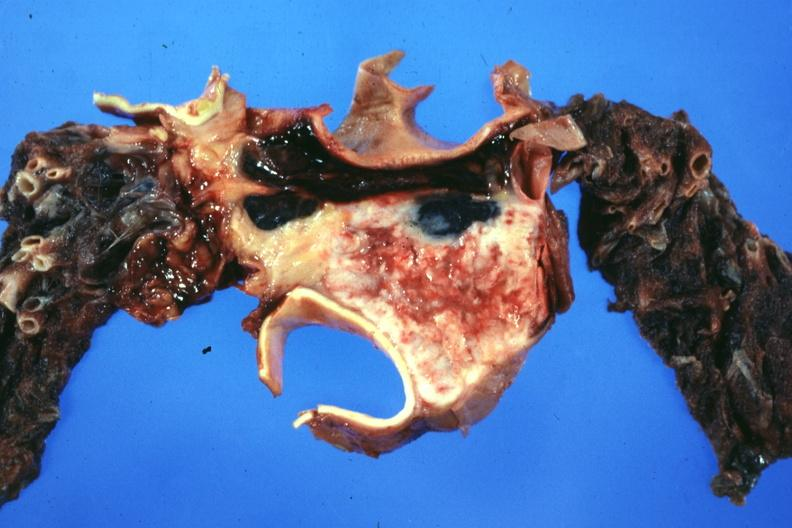s mixed mesodermal tumor present?
Answer the question using a single word or phrase. No 